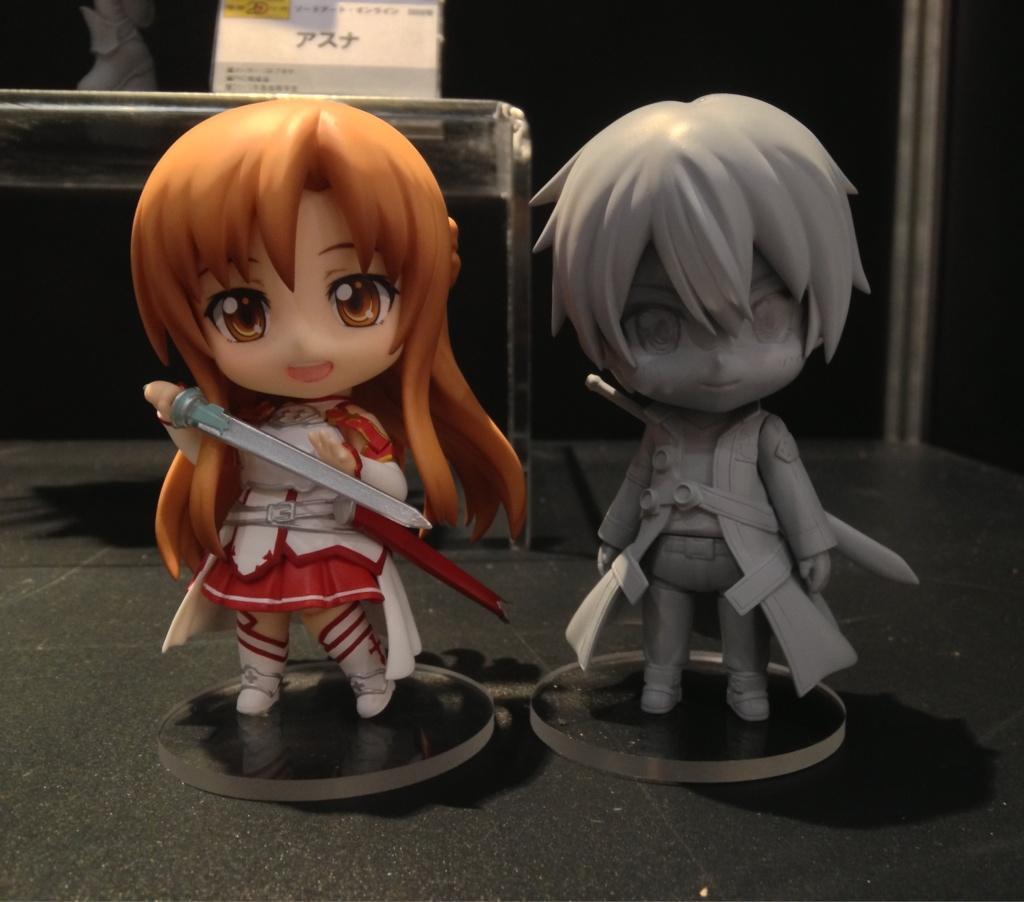Please provide a concise description of this image. In this image there is a girl and a boy toy on the floor. Behind it there is a table having a board on it. Girl toy is holding a sword in her hand. Boy toy is wearing a jacket and carrying a sword with him. 